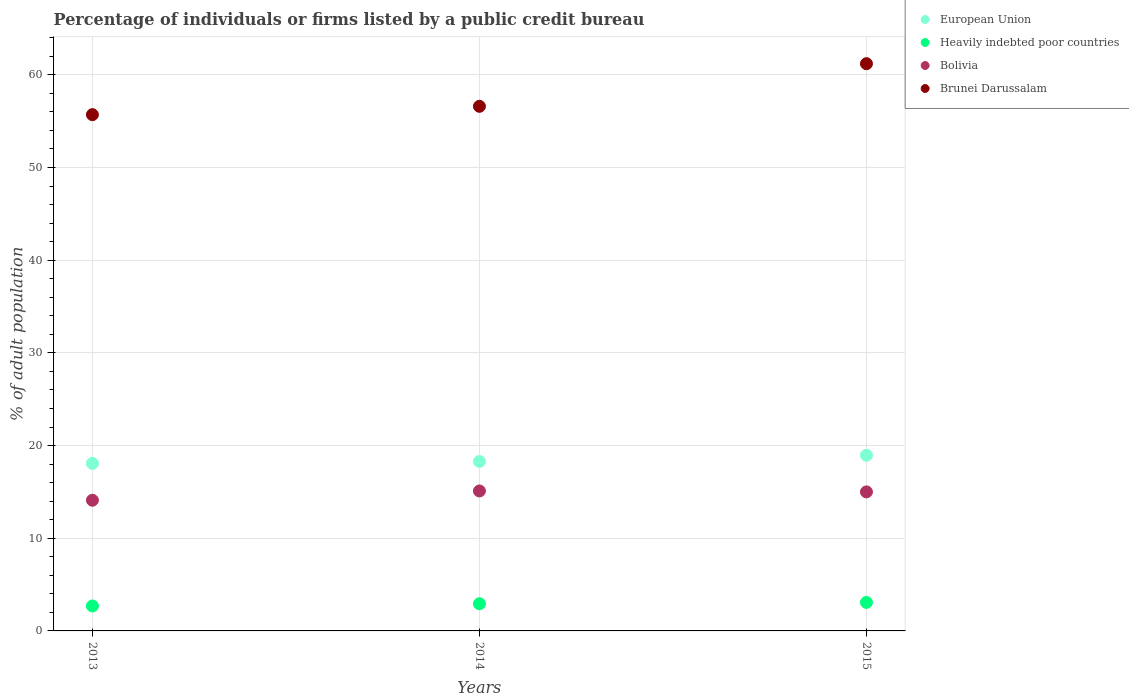What is the percentage of population listed by a public credit bureau in Brunei Darussalam in 2013?
Give a very brief answer. 55.7. Across all years, what is the maximum percentage of population listed by a public credit bureau in Heavily indebted poor countries?
Offer a terse response. 3.07. Across all years, what is the minimum percentage of population listed by a public credit bureau in Bolivia?
Make the answer very short. 14.1. In which year was the percentage of population listed by a public credit bureau in European Union maximum?
Your answer should be compact. 2015. What is the total percentage of population listed by a public credit bureau in Brunei Darussalam in the graph?
Give a very brief answer. 173.5. What is the difference between the percentage of population listed by a public credit bureau in Bolivia in 2013 and that in 2015?
Make the answer very short. -0.9. What is the difference between the percentage of population listed by a public credit bureau in Heavily indebted poor countries in 2013 and the percentage of population listed by a public credit bureau in Bolivia in 2014?
Offer a very short reply. -12.41. What is the average percentage of population listed by a public credit bureau in European Union per year?
Your answer should be compact. 18.44. In the year 2013, what is the difference between the percentage of population listed by a public credit bureau in Heavily indebted poor countries and percentage of population listed by a public credit bureau in European Union?
Give a very brief answer. -15.38. In how many years, is the percentage of population listed by a public credit bureau in European Union greater than 6 %?
Provide a short and direct response. 3. What is the ratio of the percentage of population listed by a public credit bureau in Brunei Darussalam in 2013 to that in 2014?
Your response must be concise. 0.98. Is the percentage of population listed by a public credit bureau in European Union in 2014 less than that in 2015?
Provide a succinct answer. Yes. Is the difference between the percentage of population listed by a public credit bureau in Heavily indebted poor countries in 2013 and 2014 greater than the difference between the percentage of population listed by a public credit bureau in European Union in 2013 and 2014?
Provide a succinct answer. No. What is the difference between the highest and the second highest percentage of population listed by a public credit bureau in European Union?
Offer a very short reply. 0.66. What is the difference between the highest and the lowest percentage of population listed by a public credit bureau in Bolivia?
Offer a terse response. 1. In how many years, is the percentage of population listed by a public credit bureau in European Union greater than the average percentage of population listed by a public credit bureau in European Union taken over all years?
Give a very brief answer. 1. Is the sum of the percentage of population listed by a public credit bureau in Bolivia in 2013 and 2014 greater than the maximum percentage of population listed by a public credit bureau in Heavily indebted poor countries across all years?
Your response must be concise. Yes. Does the percentage of population listed by a public credit bureau in European Union monotonically increase over the years?
Make the answer very short. Yes. Is the percentage of population listed by a public credit bureau in Heavily indebted poor countries strictly less than the percentage of population listed by a public credit bureau in Brunei Darussalam over the years?
Your answer should be compact. Yes. What is the difference between two consecutive major ticks on the Y-axis?
Your response must be concise. 10. Does the graph contain any zero values?
Ensure brevity in your answer.  No. Does the graph contain grids?
Ensure brevity in your answer.  Yes. What is the title of the graph?
Ensure brevity in your answer.  Percentage of individuals or firms listed by a public credit bureau. Does "Sri Lanka" appear as one of the legend labels in the graph?
Keep it short and to the point. No. What is the label or title of the X-axis?
Provide a short and direct response. Years. What is the label or title of the Y-axis?
Your response must be concise. % of adult population. What is the % of adult population in European Union in 2013?
Your answer should be compact. 18.07. What is the % of adult population in Heavily indebted poor countries in 2013?
Offer a very short reply. 2.69. What is the % of adult population of Bolivia in 2013?
Your answer should be compact. 14.1. What is the % of adult population of Brunei Darussalam in 2013?
Your answer should be compact. 55.7. What is the % of adult population of European Union in 2014?
Provide a succinct answer. 18.29. What is the % of adult population of Heavily indebted poor countries in 2014?
Give a very brief answer. 2.93. What is the % of adult population of Brunei Darussalam in 2014?
Provide a succinct answer. 56.6. What is the % of adult population of European Union in 2015?
Provide a succinct answer. 18.95. What is the % of adult population in Heavily indebted poor countries in 2015?
Offer a terse response. 3.07. What is the % of adult population of Bolivia in 2015?
Your answer should be very brief. 15. What is the % of adult population of Brunei Darussalam in 2015?
Your response must be concise. 61.2. Across all years, what is the maximum % of adult population of European Union?
Make the answer very short. 18.95. Across all years, what is the maximum % of adult population of Heavily indebted poor countries?
Keep it short and to the point. 3.07. Across all years, what is the maximum % of adult population of Bolivia?
Give a very brief answer. 15.1. Across all years, what is the maximum % of adult population of Brunei Darussalam?
Offer a very short reply. 61.2. Across all years, what is the minimum % of adult population in European Union?
Offer a terse response. 18.07. Across all years, what is the minimum % of adult population in Heavily indebted poor countries?
Make the answer very short. 2.69. Across all years, what is the minimum % of adult population of Bolivia?
Offer a very short reply. 14.1. Across all years, what is the minimum % of adult population of Brunei Darussalam?
Give a very brief answer. 55.7. What is the total % of adult population in European Union in the graph?
Your response must be concise. 55.31. What is the total % of adult population in Heavily indebted poor countries in the graph?
Ensure brevity in your answer.  8.7. What is the total % of adult population of Bolivia in the graph?
Your response must be concise. 44.2. What is the total % of adult population in Brunei Darussalam in the graph?
Ensure brevity in your answer.  173.5. What is the difference between the % of adult population in European Union in 2013 and that in 2014?
Your answer should be compact. -0.21. What is the difference between the % of adult population of Heavily indebted poor countries in 2013 and that in 2014?
Provide a succinct answer. -0.24. What is the difference between the % of adult population of European Union in 2013 and that in 2015?
Provide a short and direct response. -0.88. What is the difference between the % of adult population in Heavily indebted poor countries in 2013 and that in 2015?
Make the answer very short. -0.38. What is the difference between the % of adult population in Brunei Darussalam in 2013 and that in 2015?
Offer a very short reply. -5.5. What is the difference between the % of adult population of European Union in 2014 and that in 2015?
Offer a very short reply. -0.66. What is the difference between the % of adult population of Heavily indebted poor countries in 2014 and that in 2015?
Give a very brief answer. -0.14. What is the difference between the % of adult population of Brunei Darussalam in 2014 and that in 2015?
Your answer should be very brief. -4.6. What is the difference between the % of adult population of European Union in 2013 and the % of adult population of Heavily indebted poor countries in 2014?
Provide a short and direct response. 15.14. What is the difference between the % of adult population in European Union in 2013 and the % of adult population in Bolivia in 2014?
Keep it short and to the point. 2.98. What is the difference between the % of adult population of European Union in 2013 and the % of adult population of Brunei Darussalam in 2014?
Provide a succinct answer. -38.52. What is the difference between the % of adult population in Heavily indebted poor countries in 2013 and the % of adult population in Bolivia in 2014?
Keep it short and to the point. -12.41. What is the difference between the % of adult population in Heavily indebted poor countries in 2013 and the % of adult population in Brunei Darussalam in 2014?
Ensure brevity in your answer.  -53.91. What is the difference between the % of adult population of Bolivia in 2013 and the % of adult population of Brunei Darussalam in 2014?
Keep it short and to the point. -42.5. What is the difference between the % of adult population of European Union in 2013 and the % of adult population of Heavily indebted poor countries in 2015?
Give a very brief answer. 15. What is the difference between the % of adult population of European Union in 2013 and the % of adult population of Bolivia in 2015?
Your answer should be compact. 3.08. What is the difference between the % of adult population of European Union in 2013 and the % of adult population of Brunei Darussalam in 2015?
Your answer should be compact. -43.12. What is the difference between the % of adult population of Heavily indebted poor countries in 2013 and the % of adult population of Bolivia in 2015?
Ensure brevity in your answer.  -12.31. What is the difference between the % of adult population in Heavily indebted poor countries in 2013 and the % of adult population in Brunei Darussalam in 2015?
Keep it short and to the point. -58.51. What is the difference between the % of adult population in Bolivia in 2013 and the % of adult population in Brunei Darussalam in 2015?
Provide a succinct answer. -47.1. What is the difference between the % of adult population in European Union in 2014 and the % of adult population in Heavily indebted poor countries in 2015?
Provide a short and direct response. 15.21. What is the difference between the % of adult population in European Union in 2014 and the % of adult population in Bolivia in 2015?
Provide a succinct answer. 3.29. What is the difference between the % of adult population in European Union in 2014 and the % of adult population in Brunei Darussalam in 2015?
Make the answer very short. -42.91. What is the difference between the % of adult population of Heavily indebted poor countries in 2014 and the % of adult population of Bolivia in 2015?
Provide a short and direct response. -12.07. What is the difference between the % of adult population of Heavily indebted poor countries in 2014 and the % of adult population of Brunei Darussalam in 2015?
Ensure brevity in your answer.  -58.27. What is the difference between the % of adult population in Bolivia in 2014 and the % of adult population in Brunei Darussalam in 2015?
Offer a very short reply. -46.1. What is the average % of adult population of European Union per year?
Ensure brevity in your answer.  18.44. What is the average % of adult population of Heavily indebted poor countries per year?
Provide a succinct answer. 2.9. What is the average % of adult population of Bolivia per year?
Offer a terse response. 14.73. What is the average % of adult population of Brunei Darussalam per year?
Provide a succinct answer. 57.83. In the year 2013, what is the difference between the % of adult population in European Union and % of adult population in Heavily indebted poor countries?
Your answer should be compact. 15.38. In the year 2013, what is the difference between the % of adult population of European Union and % of adult population of Bolivia?
Give a very brief answer. 3.98. In the year 2013, what is the difference between the % of adult population of European Union and % of adult population of Brunei Darussalam?
Ensure brevity in your answer.  -37.62. In the year 2013, what is the difference between the % of adult population of Heavily indebted poor countries and % of adult population of Bolivia?
Your answer should be compact. -11.41. In the year 2013, what is the difference between the % of adult population in Heavily indebted poor countries and % of adult population in Brunei Darussalam?
Offer a terse response. -53.01. In the year 2013, what is the difference between the % of adult population in Bolivia and % of adult population in Brunei Darussalam?
Keep it short and to the point. -41.6. In the year 2014, what is the difference between the % of adult population in European Union and % of adult population in Heavily indebted poor countries?
Make the answer very short. 15.35. In the year 2014, what is the difference between the % of adult population of European Union and % of adult population of Bolivia?
Offer a very short reply. 3.19. In the year 2014, what is the difference between the % of adult population in European Union and % of adult population in Brunei Darussalam?
Offer a terse response. -38.31. In the year 2014, what is the difference between the % of adult population in Heavily indebted poor countries and % of adult population in Bolivia?
Offer a terse response. -12.17. In the year 2014, what is the difference between the % of adult population in Heavily indebted poor countries and % of adult population in Brunei Darussalam?
Keep it short and to the point. -53.67. In the year 2014, what is the difference between the % of adult population in Bolivia and % of adult population in Brunei Darussalam?
Your response must be concise. -41.5. In the year 2015, what is the difference between the % of adult population of European Union and % of adult population of Heavily indebted poor countries?
Offer a very short reply. 15.88. In the year 2015, what is the difference between the % of adult population in European Union and % of adult population in Bolivia?
Keep it short and to the point. 3.95. In the year 2015, what is the difference between the % of adult population in European Union and % of adult population in Brunei Darussalam?
Provide a succinct answer. -42.25. In the year 2015, what is the difference between the % of adult population of Heavily indebted poor countries and % of adult population of Bolivia?
Keep it short and to the point. -11.93. In the year 2015, what is the difference between the % of adult population of Heavily indebted poor countries and % of adult population of Brunei Darussalam?
Keep it short and to the point. -58.13. In the year 2015, what is the difference between the % of adult population of Bolivia and % of adult population of Brunei Darussalam?
Your answer should be compact. -46.2. What is the ratio of the % of adult population in Heavily indebted poor countries in 2013 to that in 2014?
Your answer should be compact. 0.92. What is the ratio of the % of adult population of Bolivia in 2013 to that in 2014?
Your response must be concise. 0.93. What is the ratio of the % of adult population of Brunei Darussalam in 2013 to that in 2014?
Give a very brief answer. 0.98. What is the ratio of the % of adult population of European Union in 2013 to that in 2015?
Keep it short and to the point. 0.95. What is the ratio of the % of adult population of Heavily indebted poor countries in 2013 to that in 2015?
Give a very brief answer. 0.88. What is the ratio of the % of adult population of Brunei Darussalam in 2013 to that in 2015?
Provide a short and direct response. 0.91. What is the ratio of the % of adult population of European Union in 2014 to that in 2015?
Give a very brief answer. 0.96. What is the ratio of the % of adult population in Heavily indebted poor countries in 2014 to that in 2015?
Give a very brief answer. 0.95. What is the ratio of the % of adult population in Brunei Darussalam in 2014 to that in 2015?
Provide a short and direct response. 0.92. What is the difference between the highest and the second highest % of adult population of European Union?
Provide a succinct answer. 0.66. What is the difference between the highest and the second highest % of adult population of Heavily indebted poor countries?
Provide a short and direct response. 0.14. What is the difference between the highest and the second highest % of adult population of Brunei Darussalam?
Provide a succinct answer. 4.6. What is the difference between the highest and the lowest % of adult population of European Union?
Keep it short and to the point. 0.88. What is the difference between the highest and the lowest % of adult population of Heavily indebted poor countries?
Keep it short and to the point. 0.38. What is the difference between the highest and the lowest % of adult population in Brunei Darussalam?
Offer a very short reply. 5.5. 